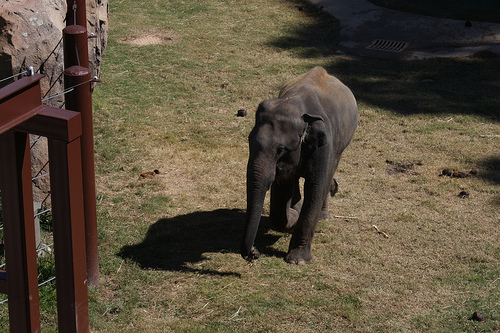<image>
Can you confirm if the elephant is under the grass? No. The elephant is not positioned under the grass. The vertical relationship between these objects is different. 